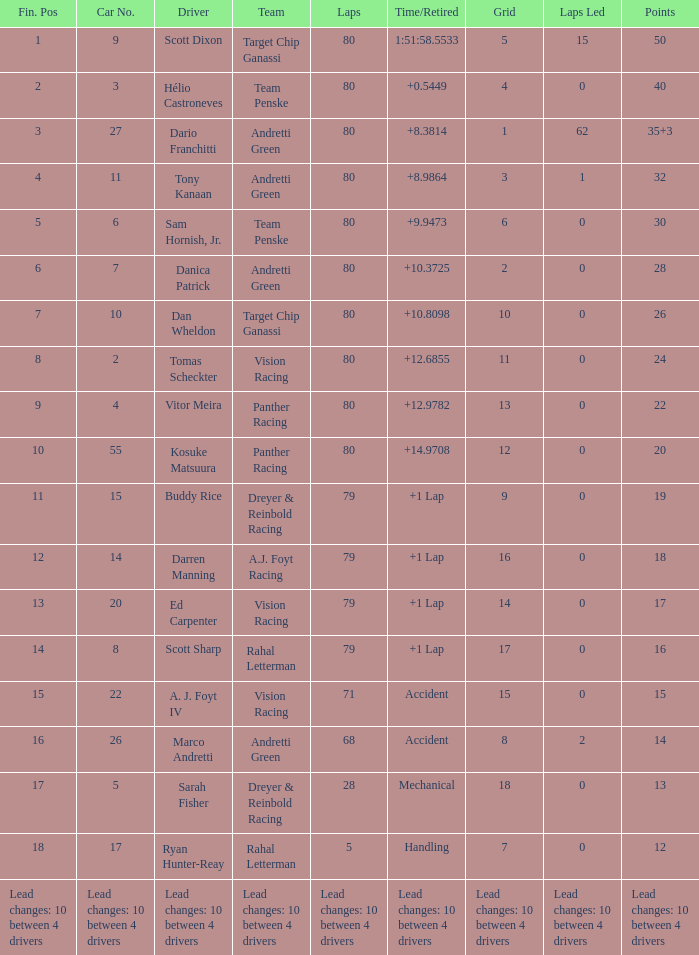Which team possesses 26 points? Target Chip Ganassi. 